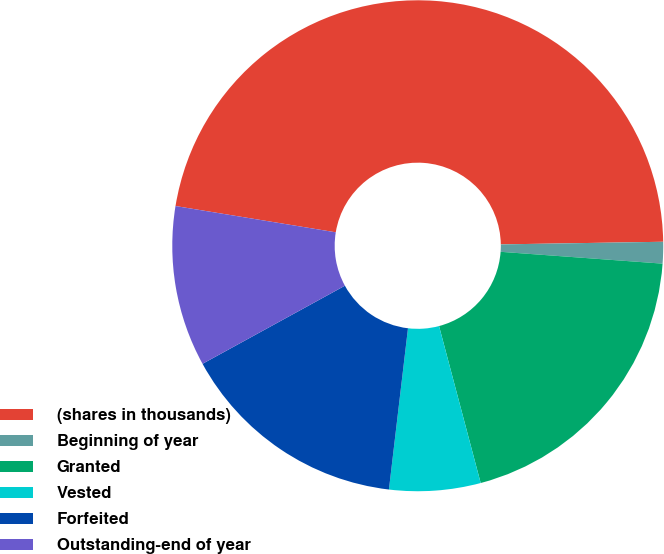Convert chart to OTSL. <chart><loc_0><loc_0><loc_500><loc_500><pie_chart><fcel>(shares in thousands)<fcel>Beginning of year<fcel>Granted<fcel>Vested<fcel>Forfeited<fcel>Outstanding-end of year<nl><fcel>47.15%<fcel>1.42%<fcel>19.71%<fcel>6.0%<fcel>15.14%<fcel>10.57%<nl></chart> 